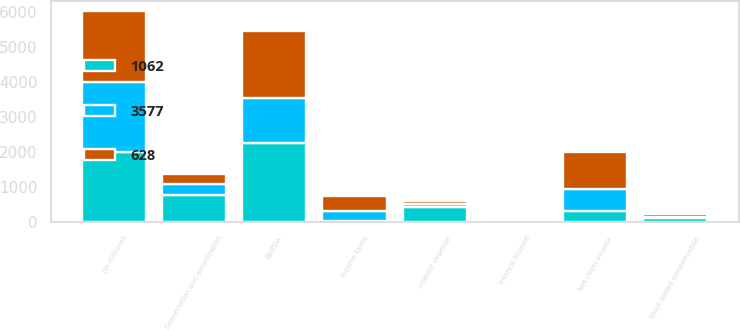Convert chart to OTSL. <chart><loc_0><loc_0><loc_500><loc_500><stacked_bar_chart><ecel><fcel>(in millions)<fcel>EBITDA<fcel>Interest income<fcel>Interest expense<fcel>Income taxes<fcel>Stock-based compensation<fcel>Depreciation and amortization<fcel>Net (loss) income<nl><fcel>1062<fcel>2006<fcel>2273<fcel>67<fcel>435<fcel>42<fcel>113<fcel>781<fcel>314<nl><fcel>3577<fcel>2005<fcel>1278<fcel>36<fcel>90<fcel>263<fcel>19<fcel>314<fcel>628<nl><fcel>628<fcel>2004<fcel>1904<fcel>20<fcel>64<fcel>432<fcel>91<fcel>275<fcel>1062<nl></chart> 